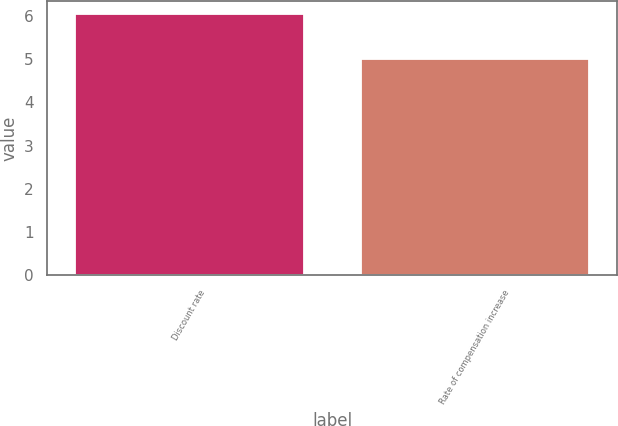Convert chart to OTSL. <chart><loc_0><loc_0><loc_500><loc_500><bar_chart><fcel>Discount rate<fcel>Rate of compensation increase<nl><fcel>6.05<fcel>5<nl></chart> 